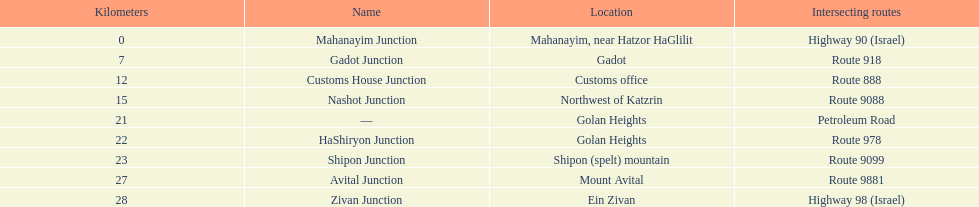Which intersection on highway 91 is nearer to ein zivan, gadot intersection or shipon intersection? Gadot Junction. 